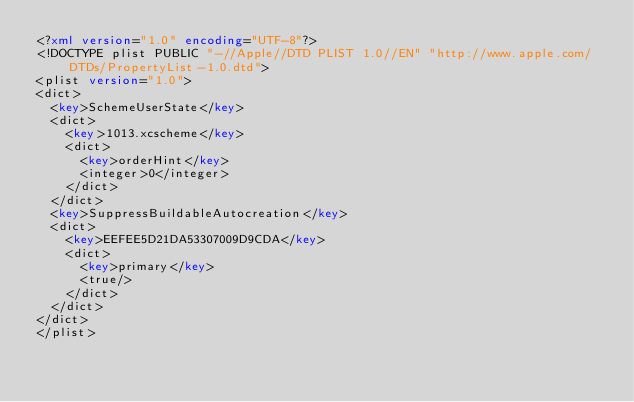Convert code to text. <code><loc_0><loc_0><loc_500><loc_500><_XML_><?xml version="1.0" encoding="UTF-8"?>
<!DOCTYPE plist PUBLIC "-//Apple//DTD PLIST 1.0//EN" "http://www.apple.com/DTDs/PropertyList-1.0.dtd">
<plist version="1.0">
<dict>
	<key>SchemeUserState</key>
	<dict>
		<key>1013.xcscheme</key>
		<dict>
			<key>orderHint</key>
			<integer>0</integer>
		</dict>
	</dict>
	<key>SuppressBuildableAutocreation</key>
	<dict>
		<key>EEFEE5D21DA53307009D9CDA</key>
		<dict>
			<key>primary</key>
			<true/>
		</dict>
	</dict>
</dict>
</plist>
</code> 